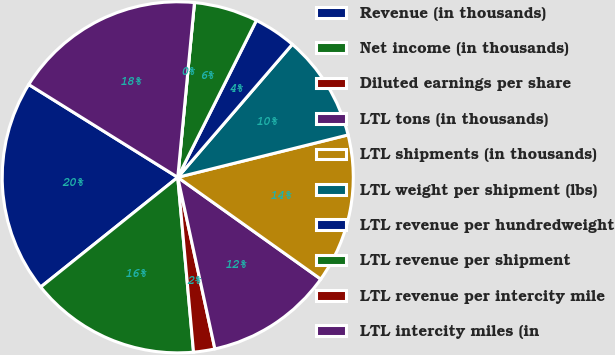<chart> <loc_0><loc_0><loc_500><loc_500><pie_chart><fcel>Revenue (in thousands)<fcel>Net income (in thousands)<fcel>Diluted earnings per share<fcel>LTL tons (in thousands)<fcel>LTL shipments (in thousands)<fcel>LTL weight per shipment (lbs)<fcel>LTL revenue per hundredweight<fcel>LTL revenue per shipment<fcel>LTL revenue per intercity mile<fcel>LTL intercity miles (in<nl><fcel>19.61%<fcel>15.69%<fcel>1.96%<fcel>11.76%<fcel>13.73%<fcel>9.8%<fcel>3.92%<fcel>5.88%<fcel>0.0%<fcel>17.65%<nl></chart> 